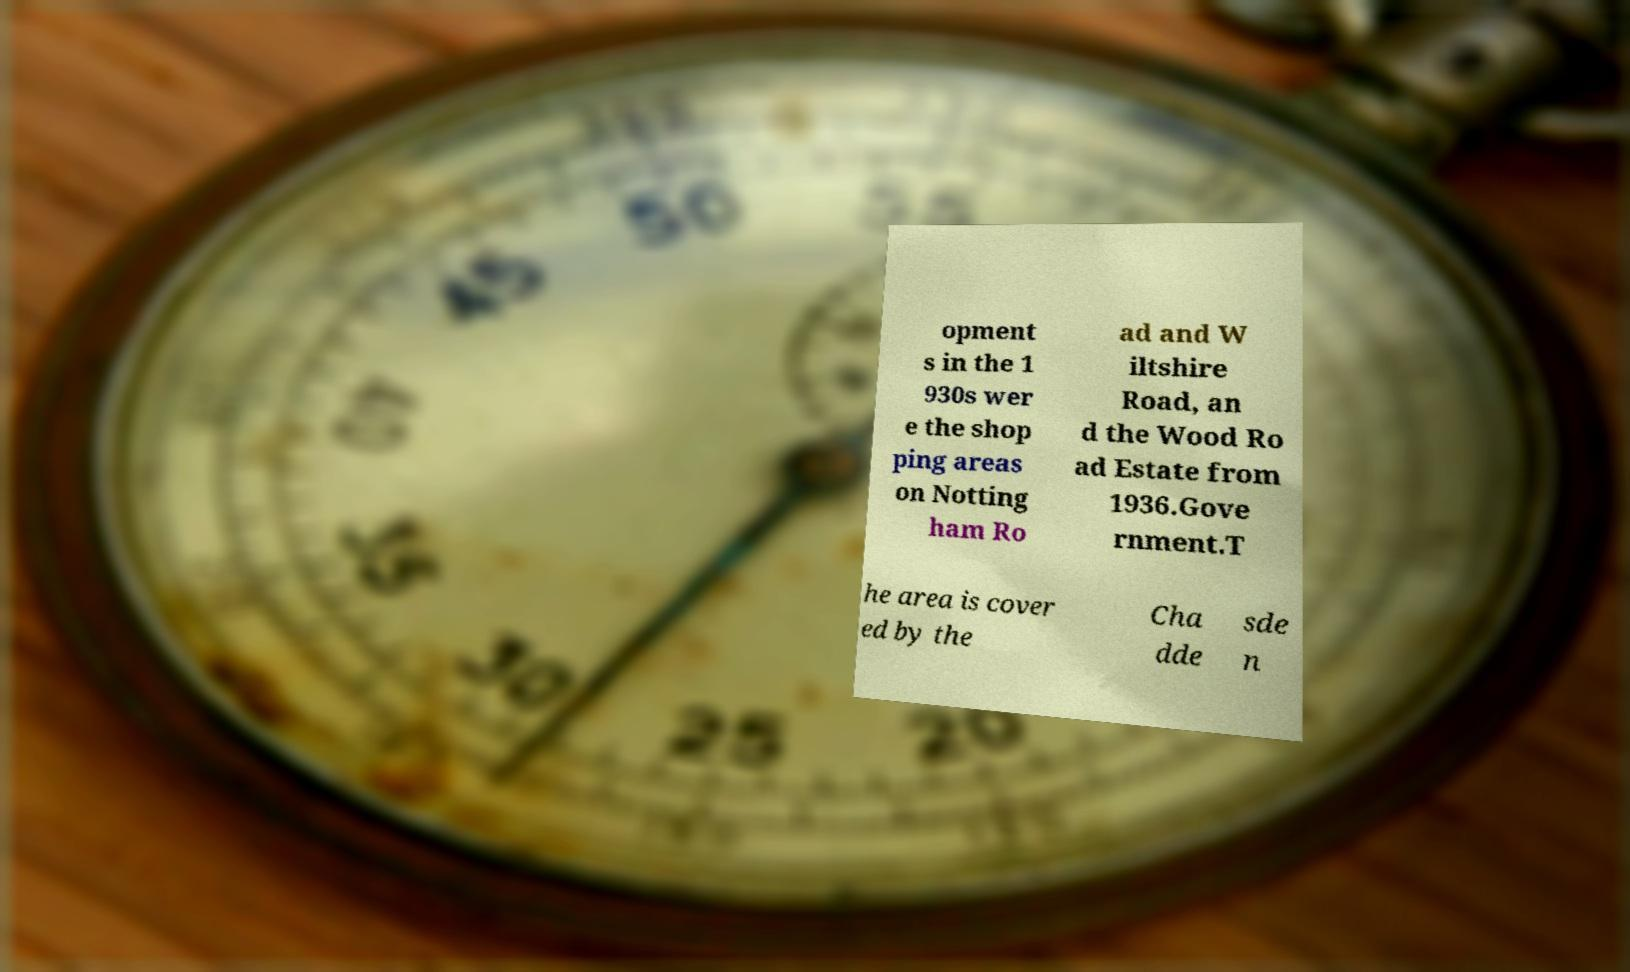Please read and relay the text visible in this image. What does it say? opment s in the 1 930s wer e the shop ping areas on Notting ham Ro ad and W iltshire Road, an d the Wood Ro ad Estate from 1936.Gove rnment.T he area is cover ed by the Cha dde sde n 